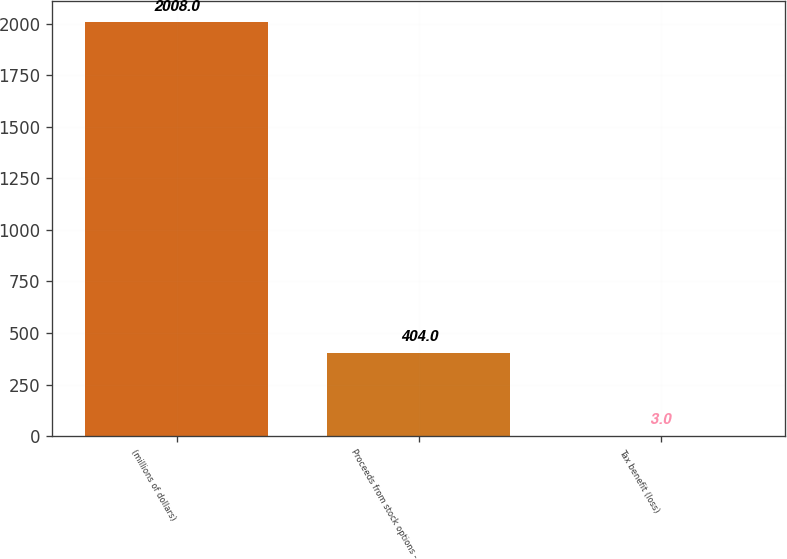<chart> <loc_0><loc_0><loc_500><loc_500><bar_chart><fcel>(millions of dollars)<fcel>Proceeds from stock options -<fcel>Tax benefit (loss)<nl><fcel>2008<fcel>404<fcel>3<nl></chart> 